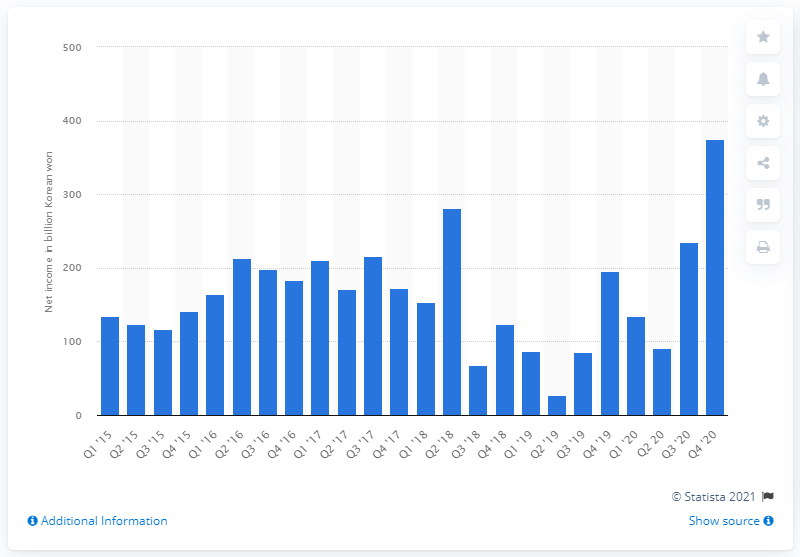Point out several critical features in this image. Naver's net income in the most recent quarter was 375.3 million. 